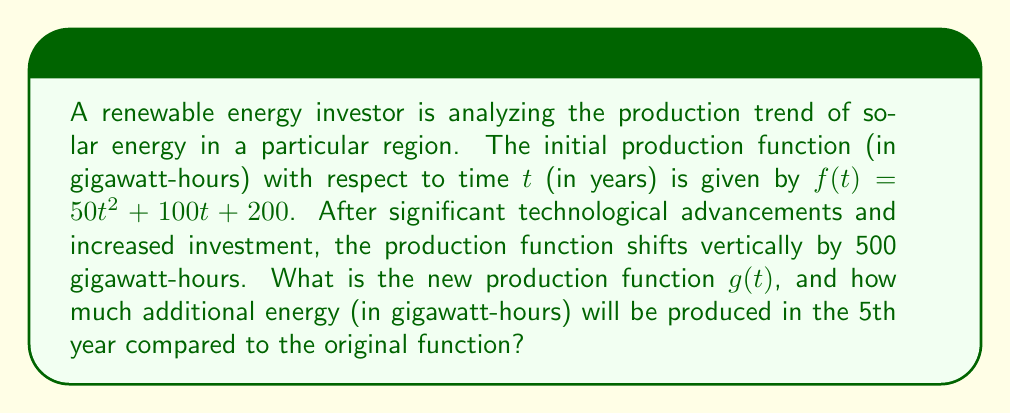Help me with this question. To solve this problem, we'll follow these steps:

1) First, let's identify the vertical shift. The production function has shifted upward by 500 gigawatt-hours. In function transformation terms, this is represented as:

   $g(t) = f(t) + 500$

2) We can now write the new function $g(t)$ by adding 500 to the original function:

   $g(t) = (50t^2 + 100t + 200) + 500$
   $g(t) = 50t^2 + 100t + 700$

3) To find how much additional energy will be produced in the 5th year, we need to:
   a) Calculate the energy produced by the original function $f(t)$ at $t=5$
   b) Calculate the energy produced by the new function $g(t)$ at $t=5$
   c) Find the difference between these values

4) For the original function $f(t)$ at $t=5$:
   
   $f(5) = 50(5^2) + 100(5) + 200$
   $f(5) = 50(25) + 500 + 200$
   $f(5) = 1250 + 500 + 200 = 1950$ gigawatt-hours

5) For the new function $g(t)$ at $t=5$:
   
   $g(5) = 50(5^2) + 100(5) + 700$
   $g(5) = 50(25) + 500 + 700$
   $g(5) = 1250 + 500 + 700 = 2450$ gigawatt-hours

6) The difference in production:
   
   $g(5) - f(5) = 2450 - 1950 = 500$ gigawatt-hours

This matches the vertical shift we applied to the function, which makes sense as the shift is constant for all values of $t$.
Answer: The new production function is $g(t) = 50t^2 + 100t + 700$, and the additional energy produced in the 5th year compared to the original function is 500 gigawatt-hours. 